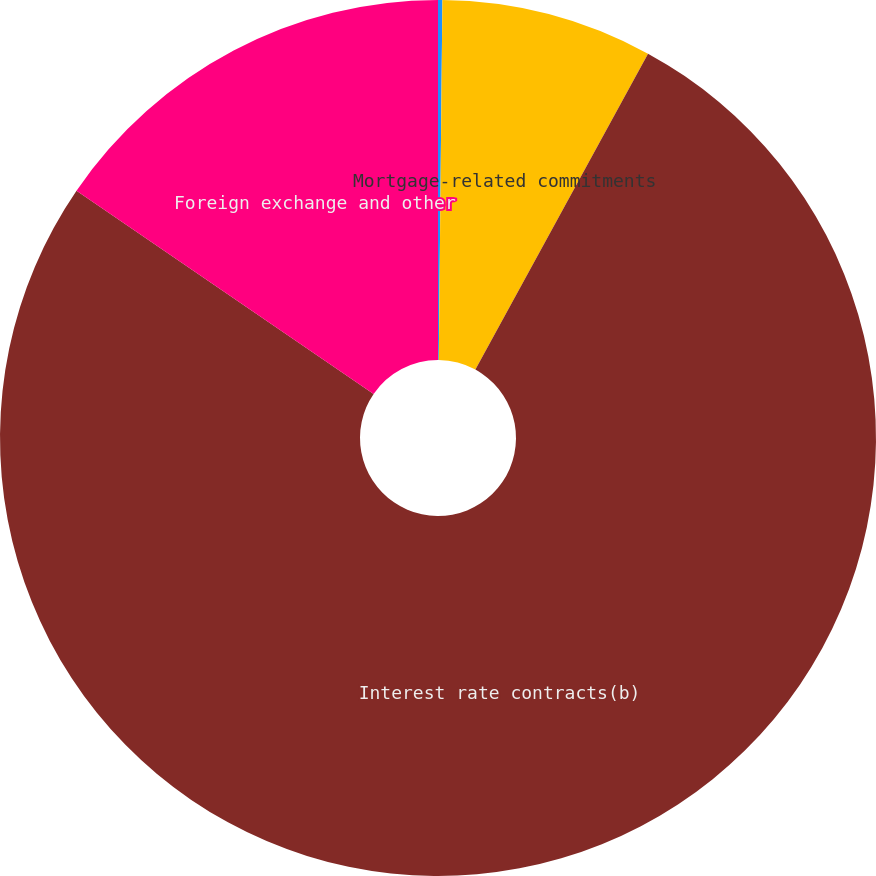Convert chart. <chart><loc_0><loc_0><loc_500><loc_500><pie_chart><fcel>Commitments to sell real<fcel>Mortgage-related commitments<fcel>Interest rate contracts(b)<fcel>Foreign exchange and other<nl><fcel>0.16%<fcel>7.8%<fcel>76.59%<fcel>15.45%<nl></chart> 